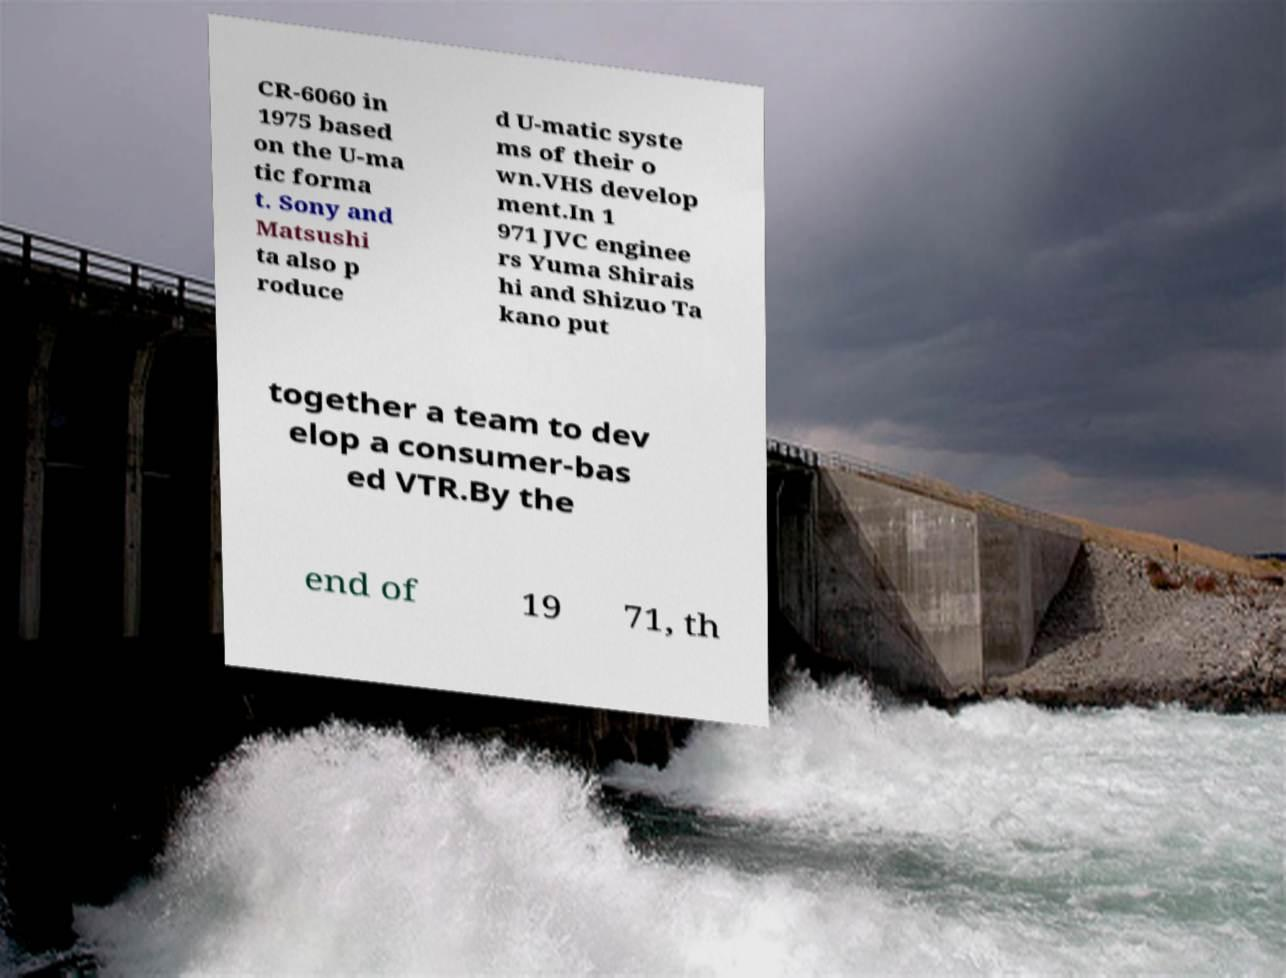There's text embedded in this image that I need extracted. Can you transcribe it verbatim? CR-6060 in 1975 based on the U-ma tic forma t. Sony and Matsushi ta also p roduce d U-matic syste ms of their o wn.VHS develop ment.In 1 971 JVC enginee rs Yuma Shirais hi and Shizuo Ta kano put together a team to dev elop a consumer-bas ed VTR.By the end of 19 71, th 